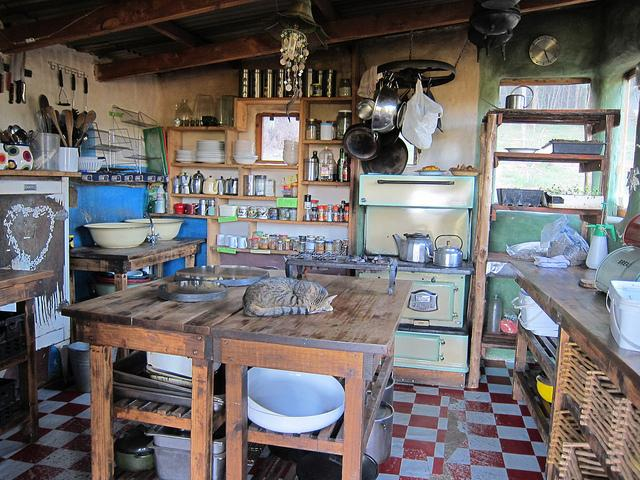What is in the kitchen but unnecessary for cooking or baking?

Choices:
A) blanket
B) radio
C) bassinet
D) cat cat 